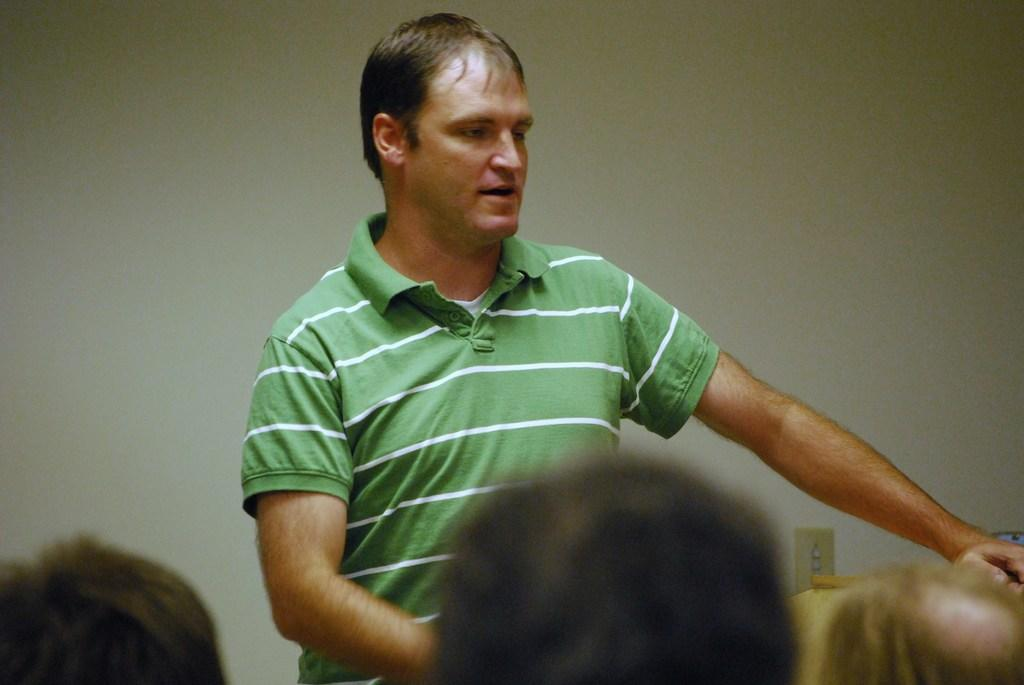What is the main subject in the middle of the image? There is a man in the middle of the image. What is the man wearing in the image? The man is wearing a t-shirt. Who else can be seen in the image besides the man? There are people at the bottom of the image. What can be seen in the background of the image? There is a wall in the background of the image. What type of receipt can be seen in the man's hand in the image? There is no receipt visible in the man's hand or anywhere else in the image. Can you tell me how many worms are crawling on the wall in the background? There are no worms present in the image; the background features a wall without any visible creatures. 